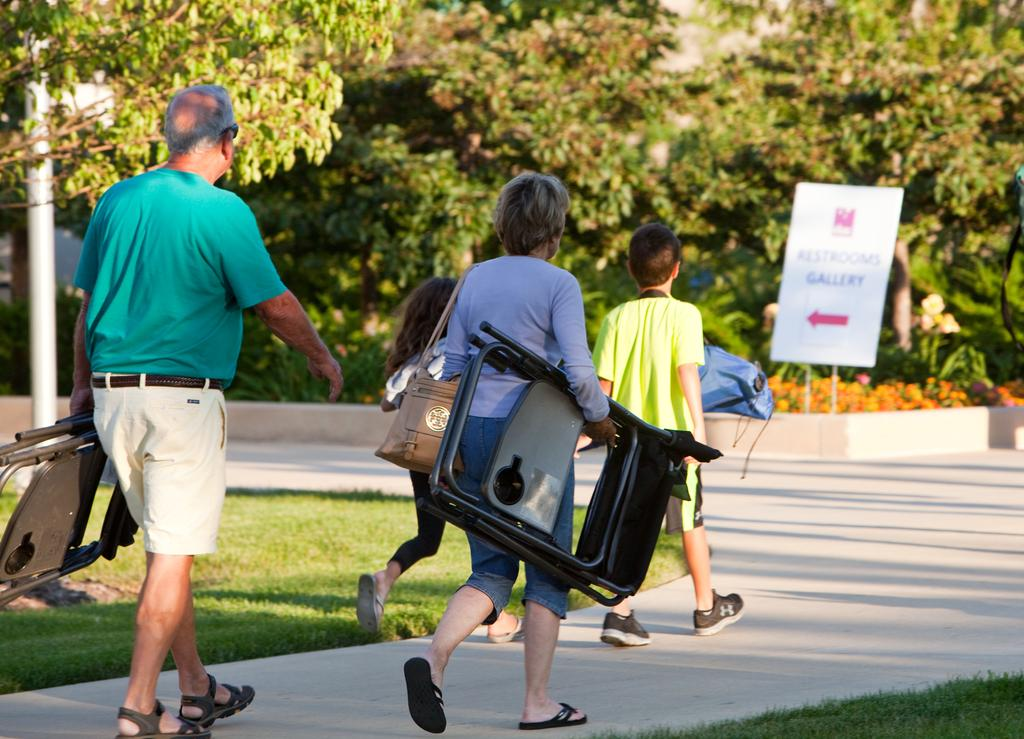How many people are in the image? There are four people in the image, two old people and two kids. What are the people doing in the image? The people are walking on a path. What are the old people holding? The old people are holding foldable chairs. What can be seen on either side of the path? There is grassland on either side of the path. What is visible in the background of the image? There are trees visible in the background. What type of lamp is being used by the sister in the image? There is no sister present in the image, and no lamp is visible. 